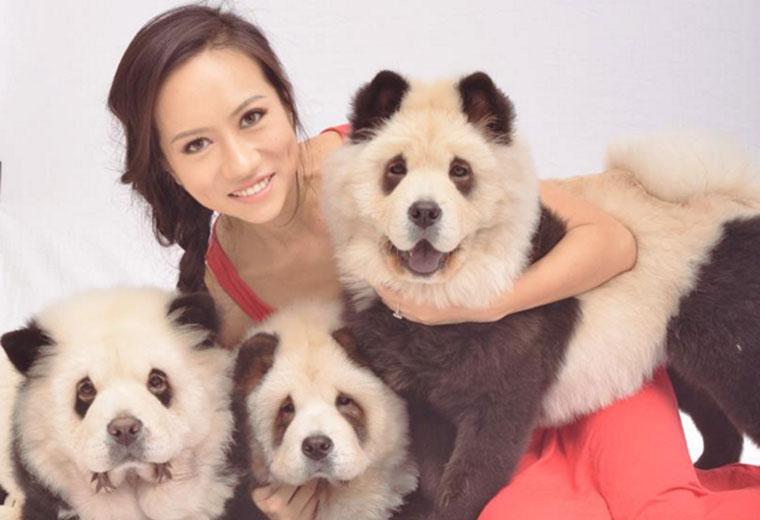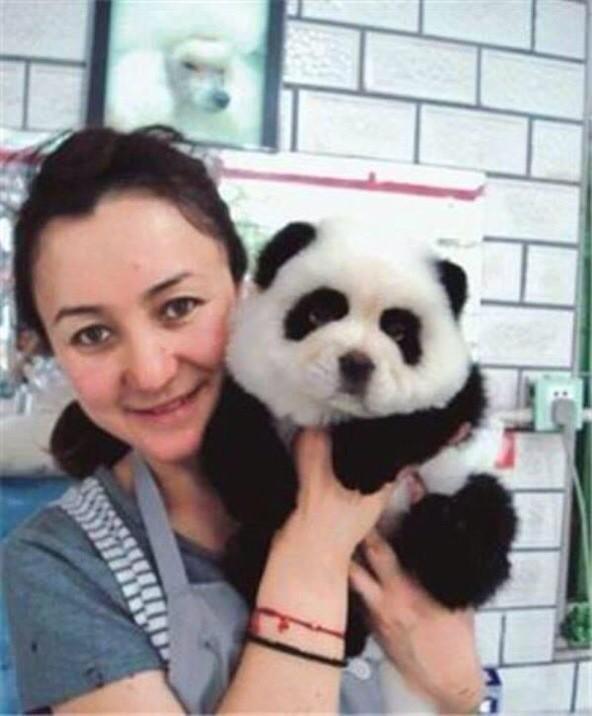The first image is the image on the left, the second image is the image on the right. For the images shown, is this caption "In one image, a woman poses with three dogs" true? Answer yes or no. Yes. 